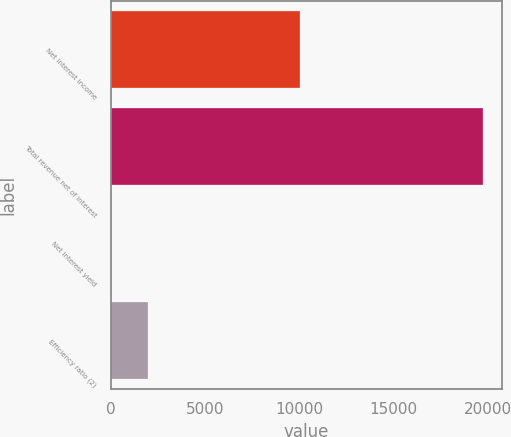Convert chart to OTSL. <chart><loc_0><loc_0><loc_500><loc_500><bar_chart><fcel>Net interest income<fcel>Total revenue net of interest<fcel>Net interest yield<fcel>Efficiency ratio (2)<nl><fcel>10032<fcel>19759<fcel>2.16<fcel>1977.84<nl></chart> 